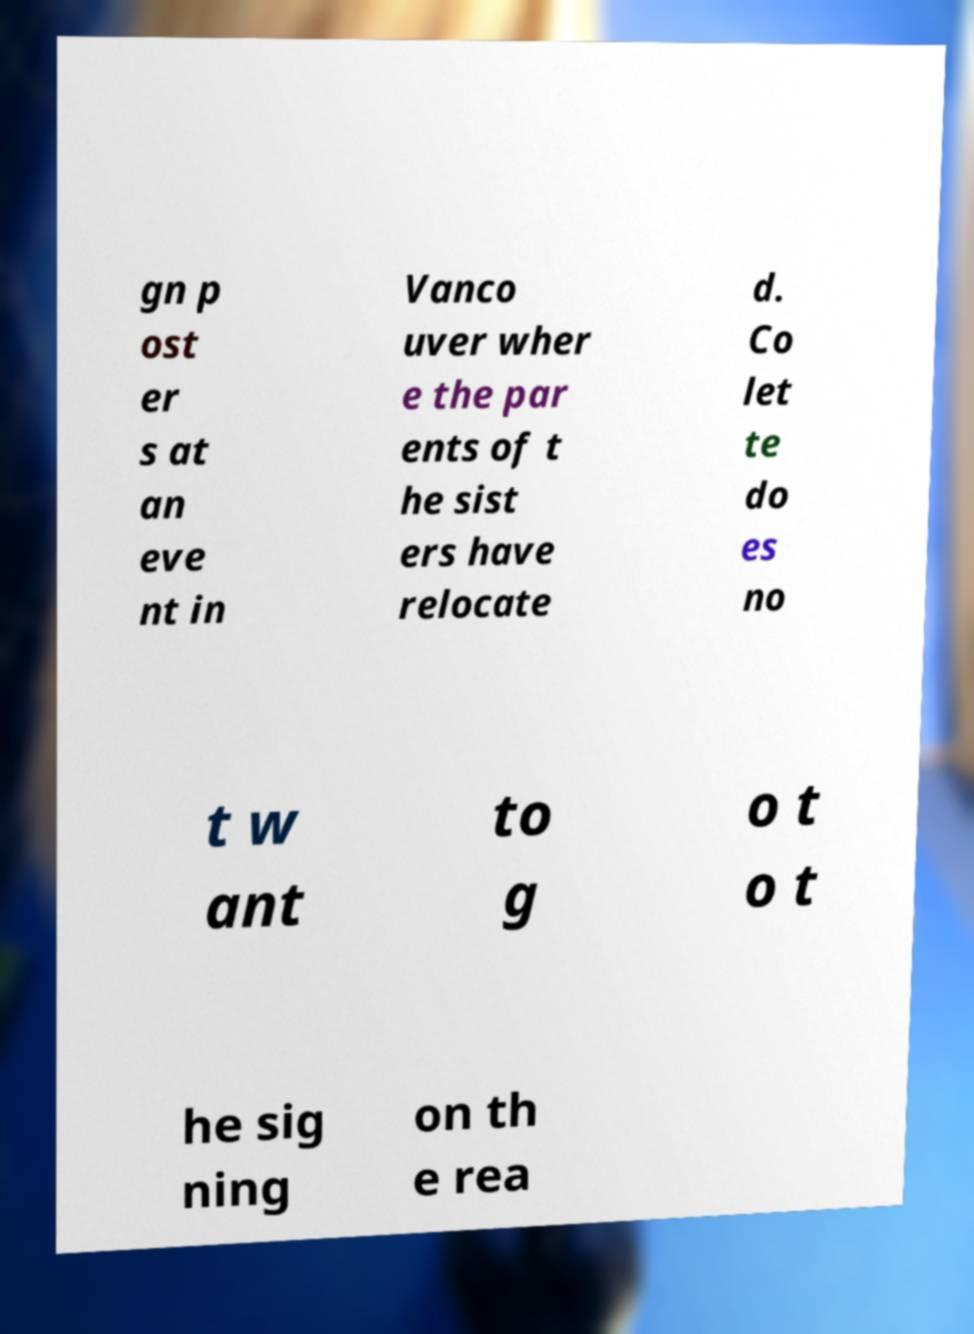Could you assist in decoding the text presented in this image and type it out clearly? gn p ost er s at an eve nt in Vanco uver wher e the par ents of t he sist ers have relocate d. Co let te do es no t w ant to g o t o t he sig ning on th e rea 